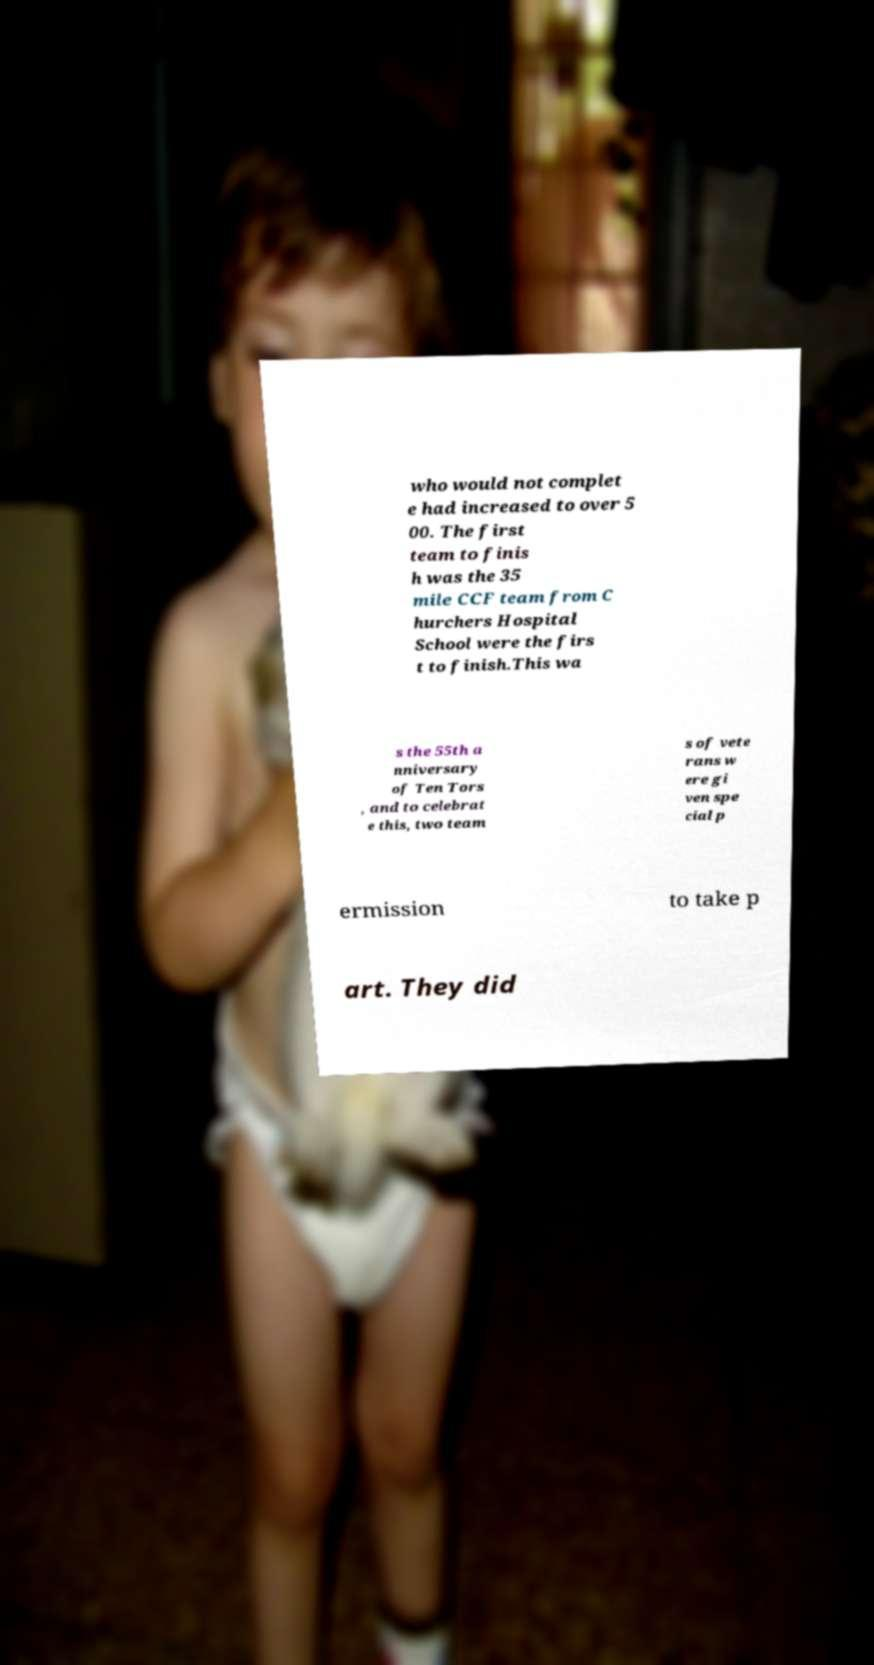For documentation purposes, I need the text within this image transcribed. Could you provide that? who would not complet e had increased to over 5 00. The first team to finis h was the 35 mile CCF team from C hurchers Hospital School were the firs t to finish.This wa s the 55th a nniversary of Ten Tors , and to celebrat e this, two team s of vete rans w ere gi ven spe cial p ermission to take p art. They did 